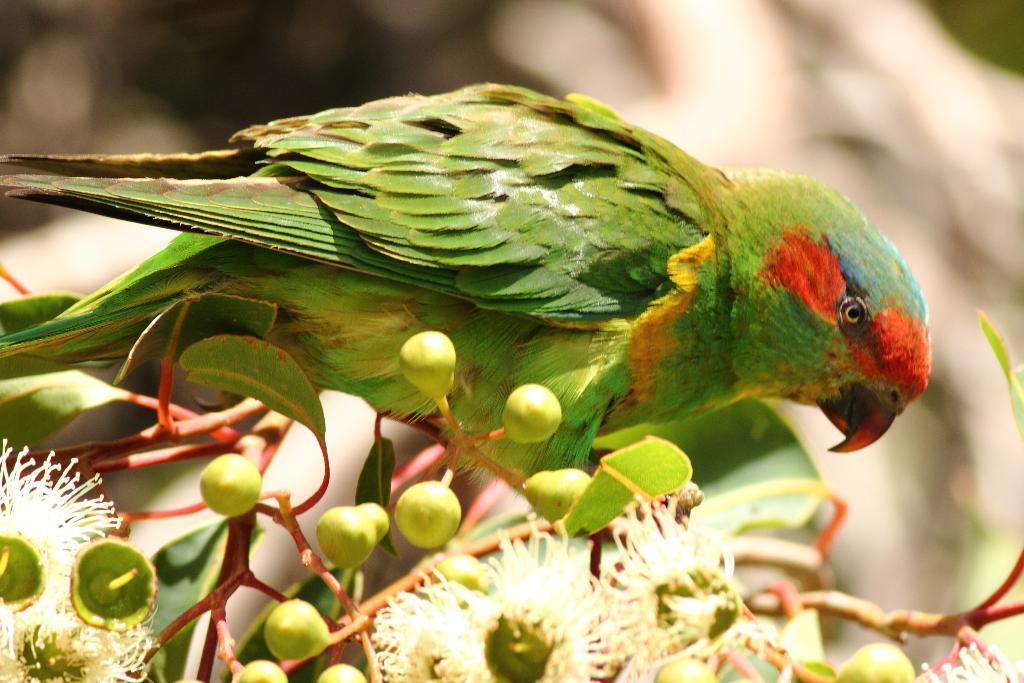Could you give a brief overview of what you see in this image? In this image we can see parrot on a plant with buds and in the background the image is blur. 